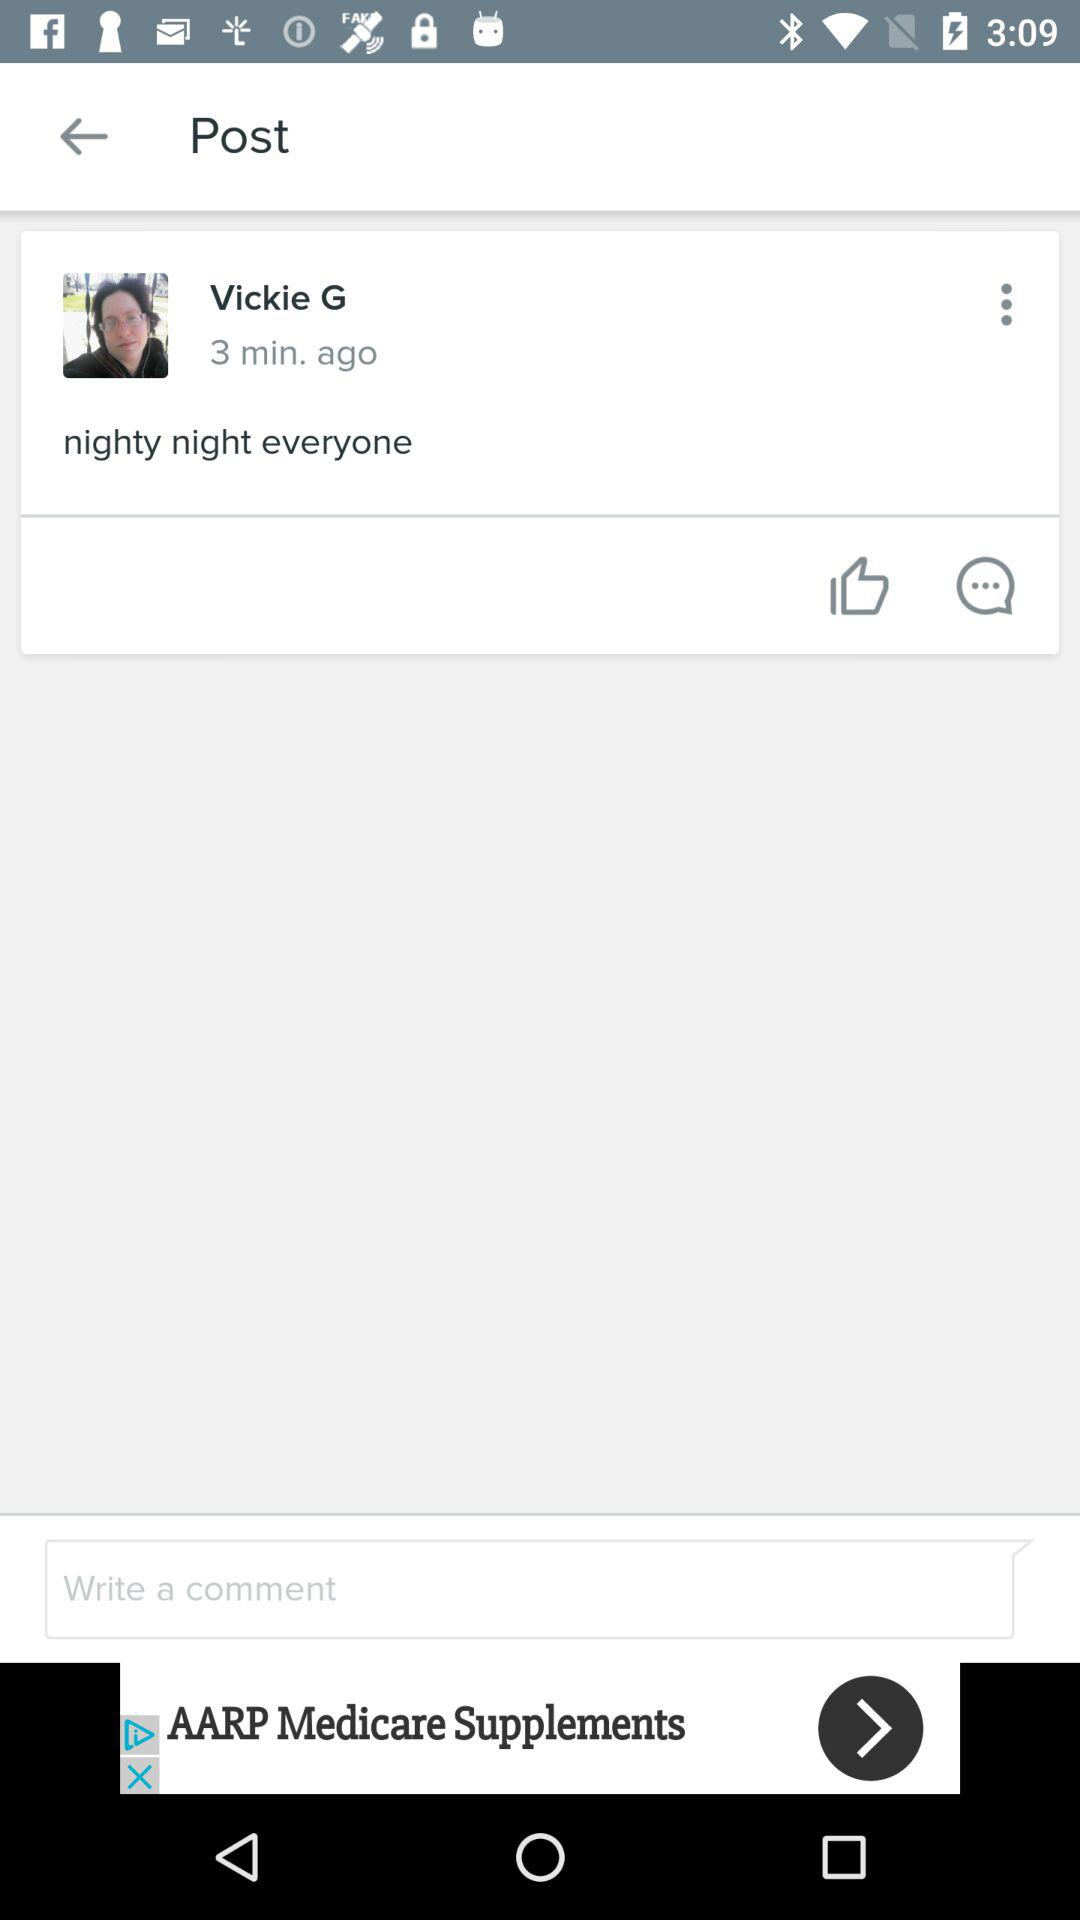What is the name of the author? The name is Vickie G. 